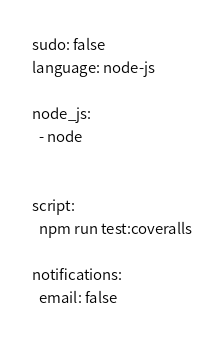<code> <loc_0><loc_0><loc_500><loc_500><_YAML_>sudo: false
language: node-js

node_js:
  - node


script:
  npm run test:coveralls

notifications:
  email: false</code> 